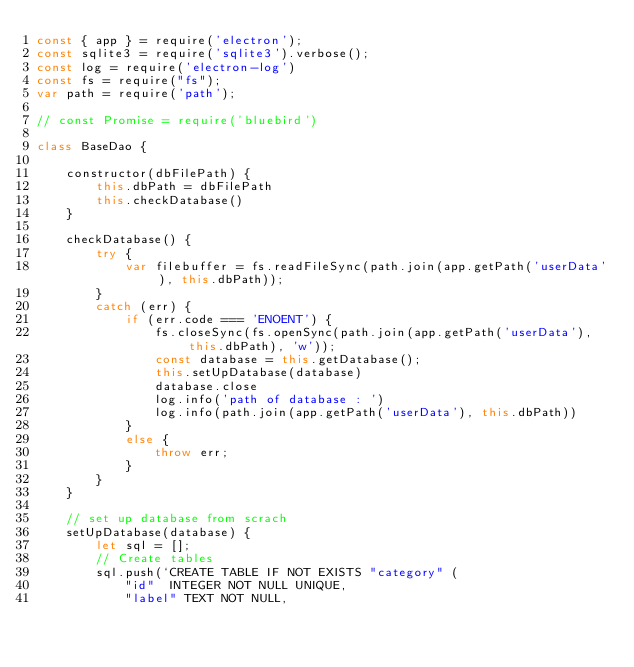Convert code to text. <code><loc_0><loc_0><loc_500><loc_500><_JavaScript_>const { app } = require('electron');
const sqlite3 = require('sqlite3').verbose();
const log = require('electron-log')
const fs = require("fs");
var path = require('path');

// const Promise = require('bluebird')

class BaseDao {

    constructor(dbFilePath) {
        this.dbPath = dbFilePath
        this.checkDatabase()
    }

    checkDatabase() {
        try {
            var filebuffer = fs.readFileSync(path.join(app.getPath('userData'), this.dbPath));
        }
        catch (err) {
            if (err.code === 'ENOENT') {
                fs.closeSync(fs.openSync(path.join(app.getPath('userData'), this.dbPath), 'w'));
                const database = this.getDatabase();
                this.setUpDatabase(database)
                database.close
                log.info('path of database : ')
                log.info(path.join(app.getPath('userData'), this.dbPath))
            } 
            else {
                throw err;
            }
        }
    }

    // set up database from scrach
    setUpDatabase(database) {
        let sql = [];
        // Create tables
        sql.push(`CREATE TABLE IF NOT EXISTS "category" (
            "id"	INTEGER NOT NULL UNIQUE,
            "label"	TEXT NOT NULL,</code> 